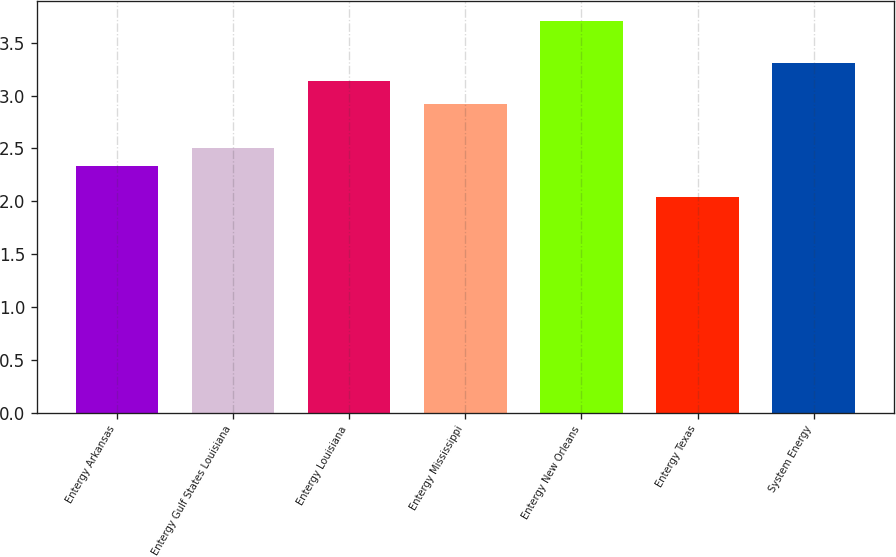Convert chart to OTSL. <chart><loc_0><loc_0><loc_500><loc_500><bar_chart><fcel>Entergy Arkansas<fcel>Entergy Gulf States Louisiana<fcel>Entergy Louisiana<fcel>Entergy Mississippi<fcel>Entergy New Orleans<fcel>Entergy Texas<fcel>System Energy<nl><fcel>2.33<fcel>2.5<fcel>3.14<fcel>2.92<fcel>3.71<fcel>2.04<fcel>3.31<nl></chart> 